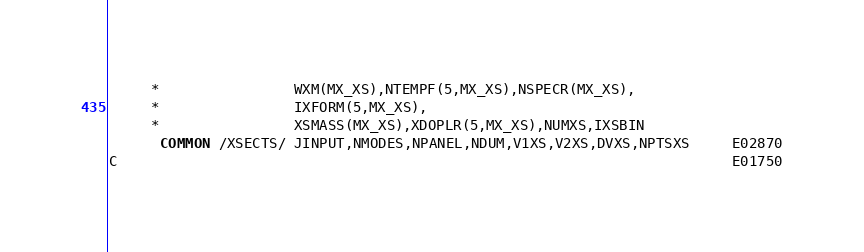<code> <loc_0><loc_0><loc_500><loc_500><_FORTRAN_>     *                WXM(MX_XS),NTEMPF(5,MX_XS),NSPECR(MX_XS),
     *                IXFORM(5,MX_XS),  
     *                XSMASS(MX_XS),XDOPLR(5,MX_XS),NUMXS,IXSBIN    
      COMMON /XSECTS/ JINPUT,NMODES,NPANEL,NDUM,V1XS,V2XS,DVXS,NPTSXS     E02870
C                                                                         E01750</code> 